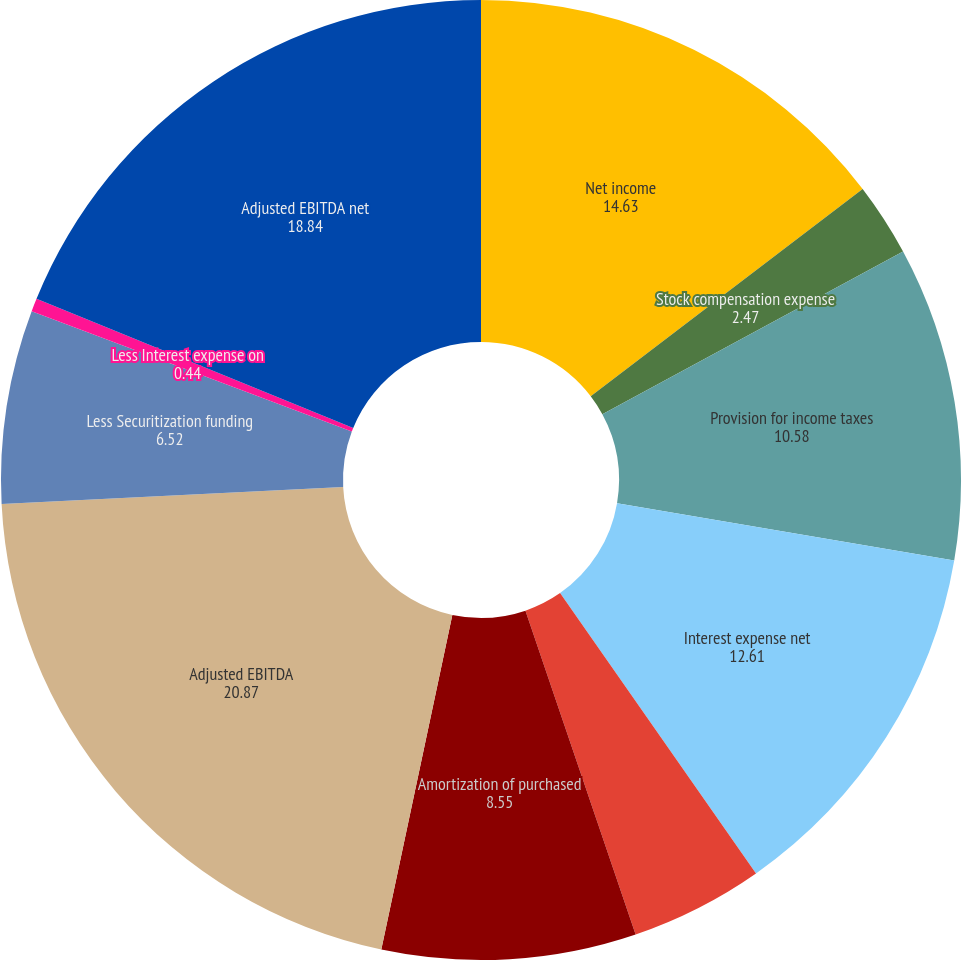Convert chart to OTSL. <chart><loc_0><loc_0><loc_500><loc_500><pie_chart><fcel>Net income<fcel>Stock compensation expense<fcel>Provision for income taxes<fcel>Interest expense net<fcel>Depreciation and other<fcel>Amortization of purchased<fcel>Adjusted EBITDA<fcel>Less Securitization funding<fcel>Less Interest expense on<fcel>Adjusted EBITDA net<nl><fcel>14.63%<fcel>2.47%<fcel>10.58%<fcel>12.61%<fcel>4.49%<fcel>8.55%<fcel>20.87%<fcel>6.52%<fcel>0.44%<fcel>18.84%<nl></chart> 